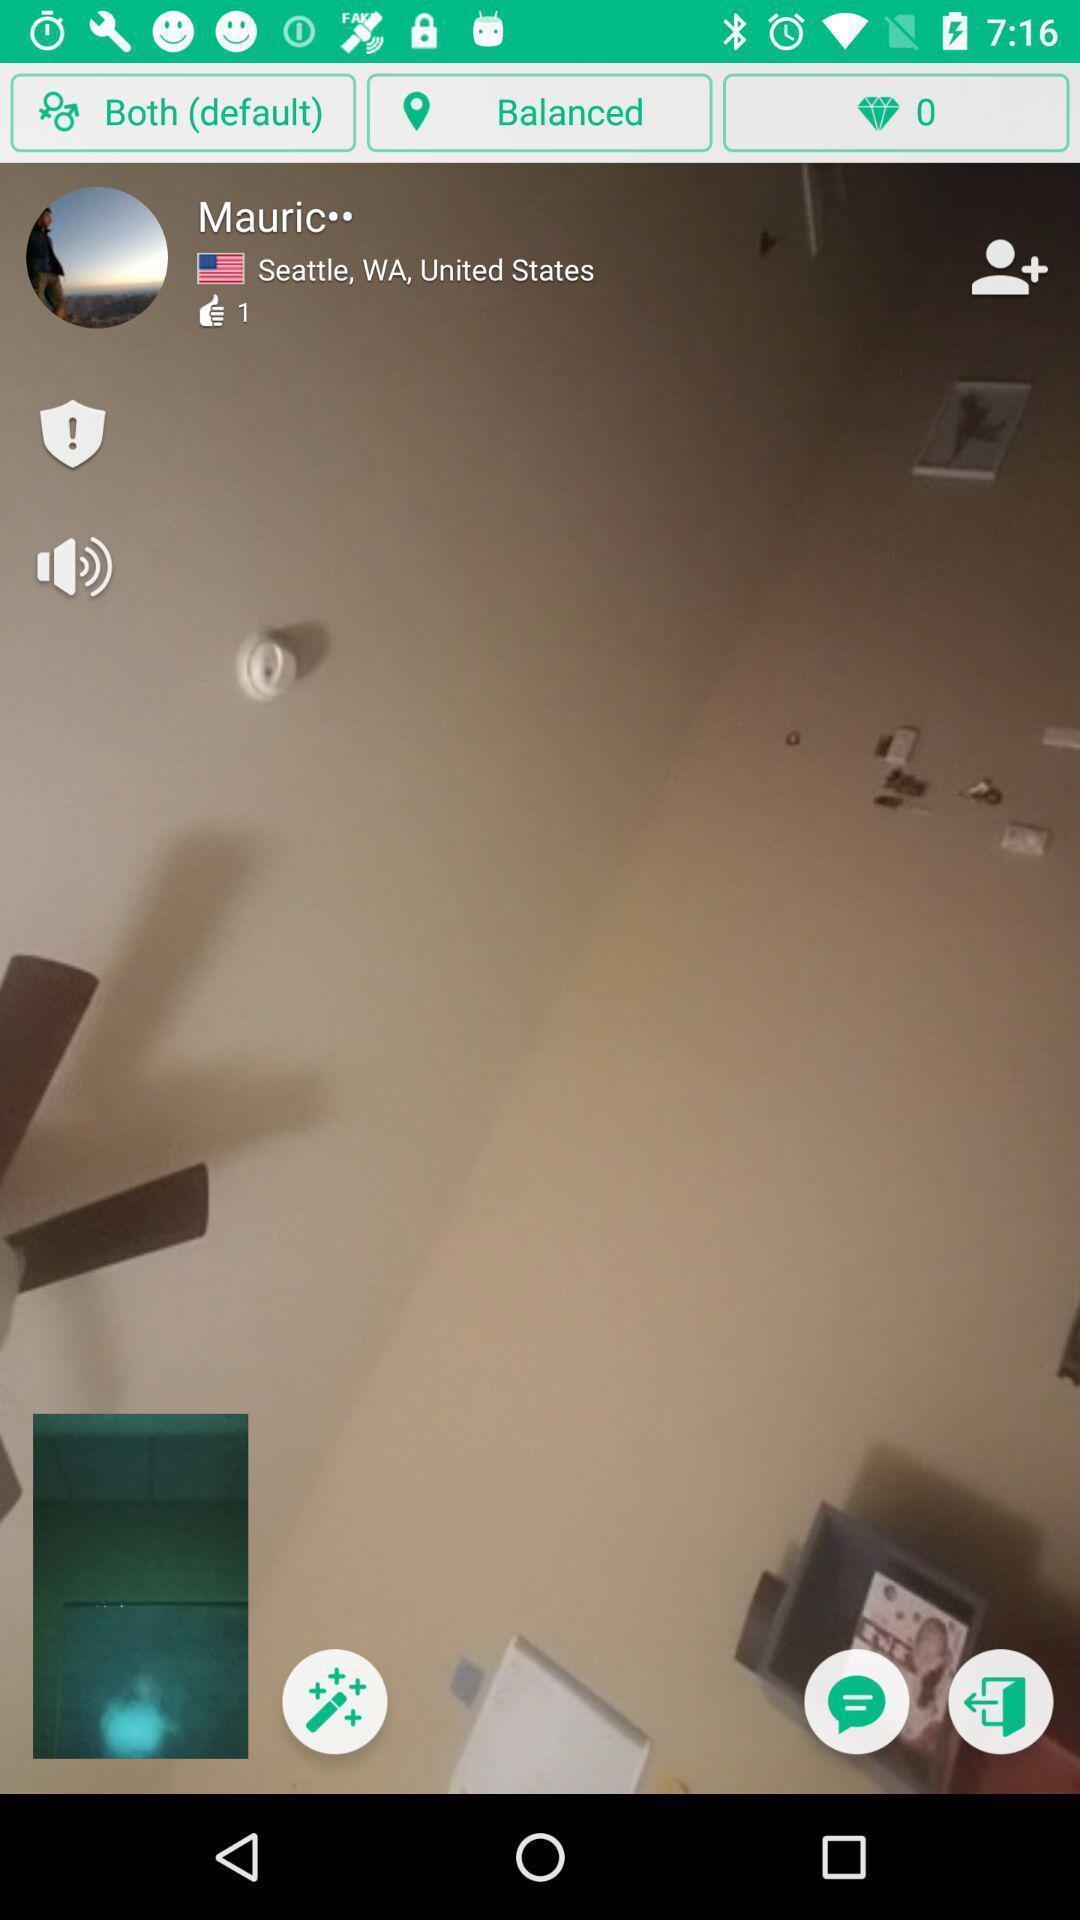Give me a summary of this screen capture. Page shows about a video calls and to chat. 